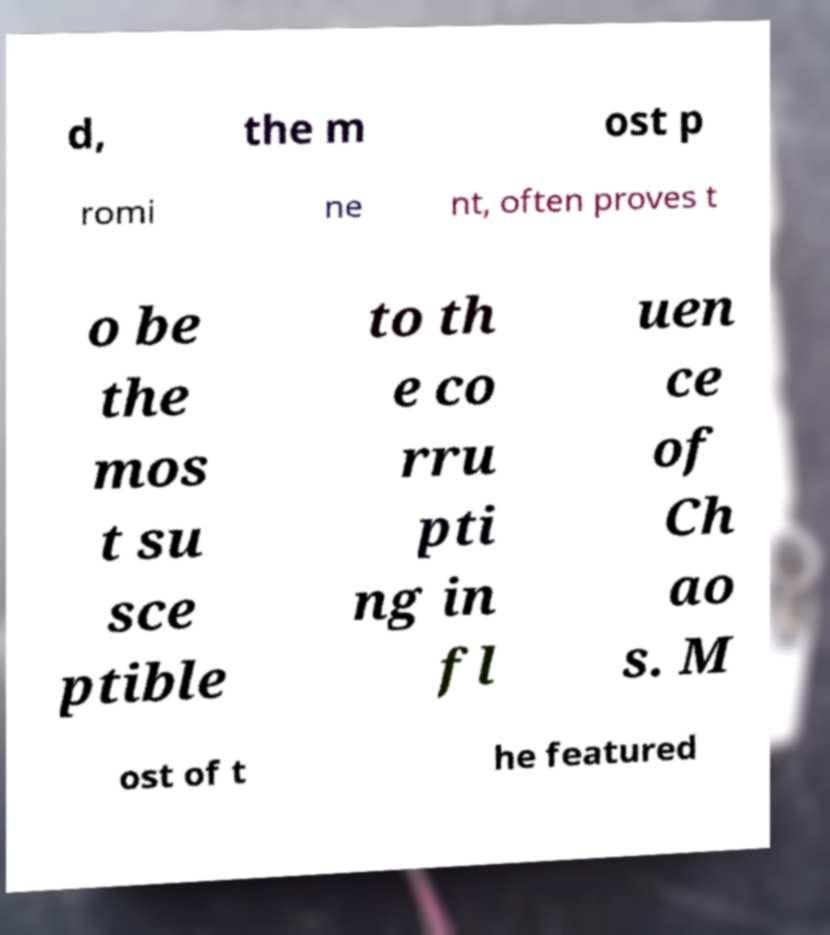Can you accurately transcribe the text from the provided image for me? d, the m ost p romi ne nt, often proves t o be the mos t su sce ptible to th e co rru pti ng in fl uen ce of Ch ao s. M ost of t he featured 